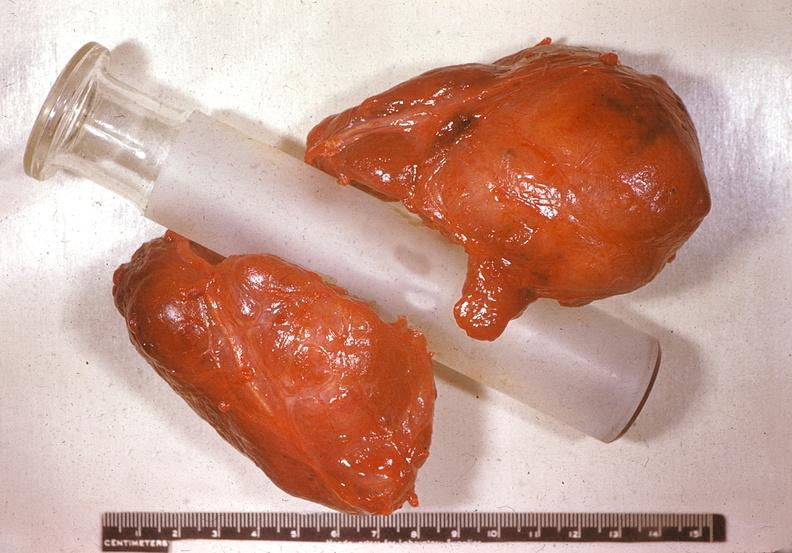s anomalous origin present?
Answer the question using a single word or phrase. No 